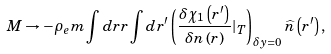<formula> <loc_0><loc_0><loc_500><loc_500>M \rightarrow - \rho _ { e } m \int d r r \int d r ^ { \prime } \left ( \frac { \delta \chi _ { 1 } \left ( r ^ { \prime } \right ) } { \delta n \left ( r \right ) } | _ { T } \right ) _ { \delta y = 0 } \widehat { n } \left ( r ^ { \prime } \right ) ,</formula> 